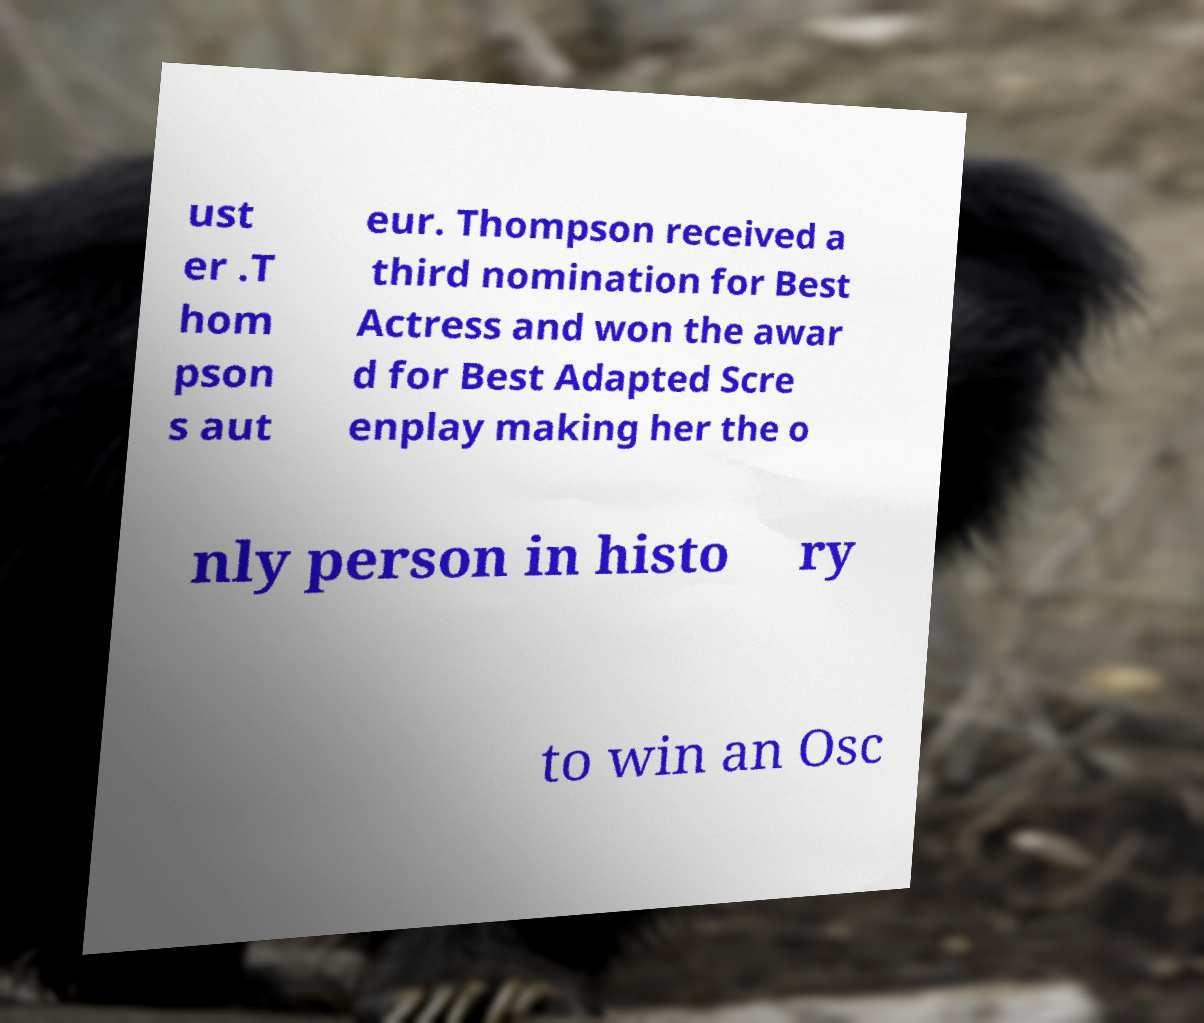Can you read and provide the text displayed in the image?This photo seems to have some interesting text. Can you extract and type it out for me? ust er .T hom pson s aut eur. Thompson received a third nomination for Best Actress and won the awar d for Best Adapted Scre enplay making her the o nly person in histo ry to win an Osc 